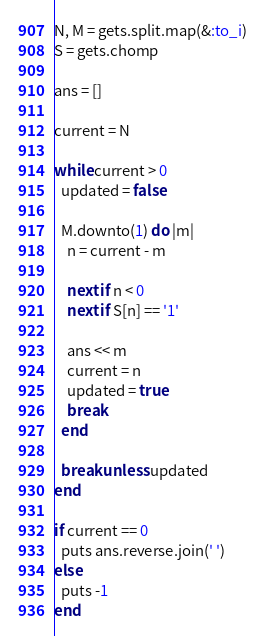Convert code to text. <code><loc_0><loc_0><loc_500><loc_500><_Ruby_>N, M = gets.split.map(&:to_i)
S = gets.chomp

ans = []

current = N

while current > 0
  updated = false

  M.downto(1) do |m|
    n = current - m

    next if n < 0
    next if S[n] == '1'

    ans << m
    current = n
    updated = true
    break
  end

  break unless updated
end

if current == 0
  puts ans.reverse.join(' ')
else
  puts -1
end
</code> 